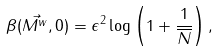<formula> <loc_0><loc_0><loc_500><loc_500>\beta ( \vec { M ^ { w } } , 0 ) = \epsilon ^ { 2 } \log \left ( 1 + \frac { 1 } { \overline { N } } \right ) ,</formula> 